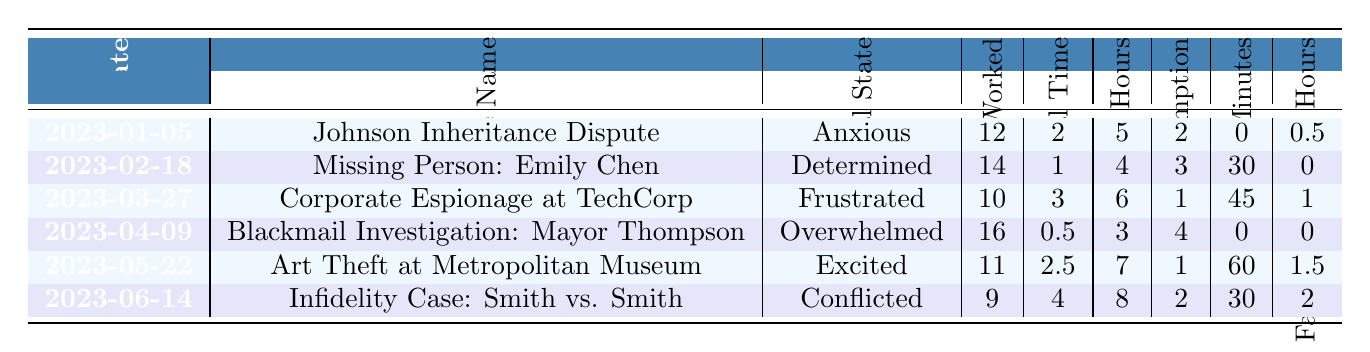What was the emotional state during the "Blackmail Investigation: Mayor Thompson" case? The emotional state listed for the "Blackmail Investigation: Mayor Thompson" on the date 2023-04-09 is "Overwhelmed."
Answer: Overwhelmed How many hours were worked on the "Art Theft at Metropolitan Museum" case? The table shows that 11 hours were worked on the "Art Theft at Metropolitan Museum" case on the date 2023-05-22.
Answer: 11 What is the average sleep hours across all cases? The total sleep hours are 5 + 4 + 6 + 3 + 7 + 8 = 33. There are 6 cases, so the average is 33/6 = 5.5.
Answer: 5.5 Did more than 3 hours of personal time occur in the "Infidelity Case: Smith vs. Smith"? The personal time for the "Infidelity Case: Smith vs. Smith" on the date 2023-06-14 is 4 hours, which is more than 3 hours.
Answer: Yes Which case had the highest alcohol consumption, and what was the amount? Looking at the alcohol consumption, "Blackmail Investigation: Mayor Thompson" has the highest amount at 4 units on 2023-04-09.
Answer: Blackmail Investigation: Mayor Thompson, 4 How many total family interaction hours were logged over all the cases? The family interaction hours are summed as 0.5 + 0 + 1 + 0 + 1.5 + 2 = 5. The total is 5 family interaction hours.
Answer: 5 What was the emotional state and personal time for the case with the least hours worked? The case with the least hours worked is "Infidelity Case: Smith vs. Smith," with 9 hours worked, and its emotional state is "Conflicted" with 4 hours of personal time.
Answer: Conflicted, 4 Which month had the highest recorded hours worked and what was the amount? The "Blackmail Investigation: Mayor Thompson" in April had the highest hours worked at 16.
Answer: April, 16 What was the sum of exercise minutes for all cases? The exercise minutes are summed as 0 + 30 + 45 + 0 + 60 + 30 = 165 minutes for all cases.
Answer: 165 Was there any month where the emotional state was classified as "Anxious"? Yes, the emotional state "Anxious" is present for the case "Johnson Inheritance Dispute" dated 2023-01-05.
Answer: Yes Which case had the highest ratio of personal time to hours worked? The "Infidelity Case: Smith vs. Smith" had 4 hours of personal time compared to 9 hours worked, giving a ratio of 4/9, which is the highest ratio among the cases.
Answer: Infidelity Case: Smith vs. Smith What proportion of cases recorded less than 3 hours of personal time? Out of 6 cases, 3 cases ("Johnson Inheritance Dispute", "Missing Person: Emily Chen", and "Blackmail Investigation: Mayor Thompson") recorded less than 3 hours of personal time, resulting in a proportion of 3/6 = 0.5.
Answer: 0.5 How does the sleep hours vary between cases associated with high emotional states like "Overwhelmed" and "Excited"? "Overwhelmed" during "Blackmail Investigation: Mayor Thompson" had 3 sleep hours, whereas "Excited" in "Art Theft at Metropolitan Museum" had 7 sleep hours, showing a difference of 4 hours.
Answer: 4 hours difference Was there a case where the sum of hours worked and personal time did not exceed 15 hours? Yes, for the "Infidelity Case: Smith vs. Smith," the sum is 9 (hours worked) + 4 (personal time) = 13 hours, not exceeding 15.
Answer: Yes What emotional state correlates with the case where the least personal time was allocated? The case "Blackmail Investigation: Mayor Thompson" had the least personal time at 0.5 hours, with the emotional state being "Overwhelmed."
Answer: Overwhelmed On which date did the detective report the least sleep, and what was that amount? On 2023-04-09, during the "Blackmail Investigation: Mayor Thompson" case, the detective reported the least sleep hours recorded at 3.
Answer: 2023-04-09, 3 hours 